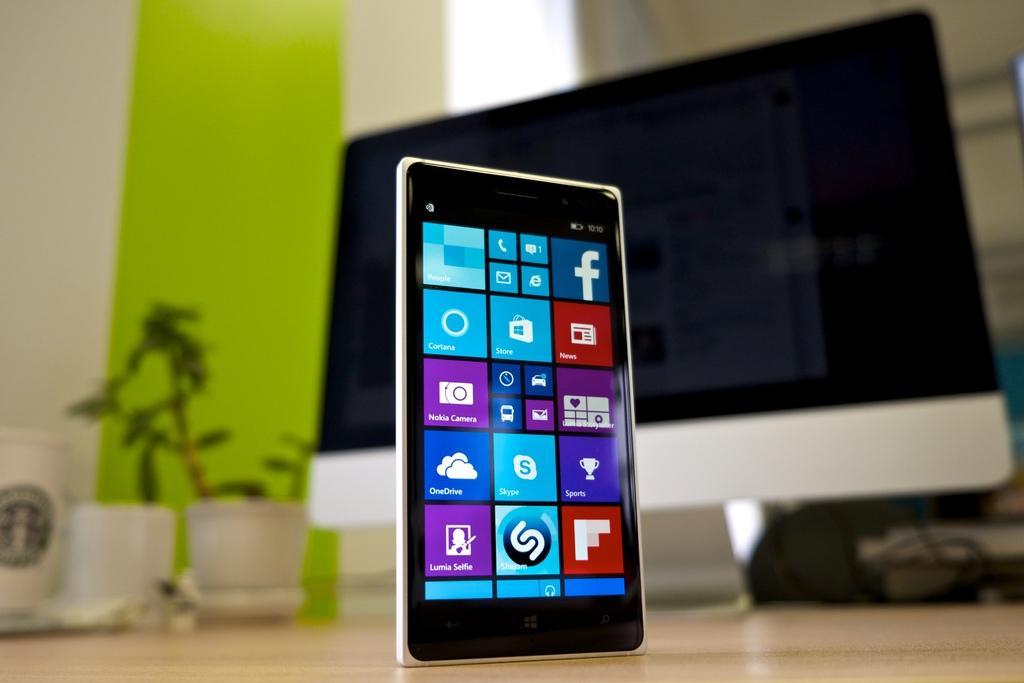Describe this image in one or two sentences. In the foreground of the image we can see a cell phone. On the top of the image we can see a monitor, but it is in a blur. 